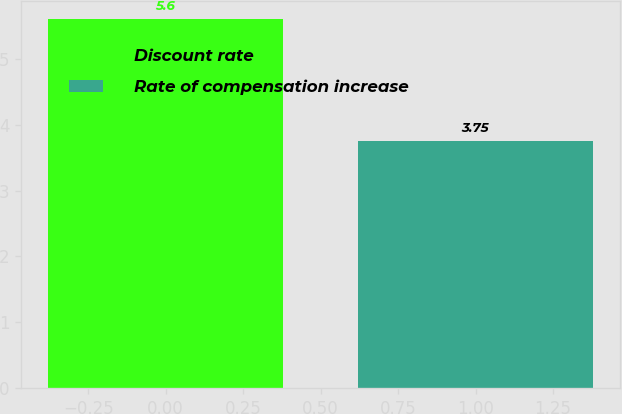Convert chart. <chart><loc_0><loc_0><loc_500><loc_500><bar_chart><fcel>Discount rate<fcel>Rate of compensation increase<nl><fcel>5.6<fcel>3.75<nl></chart> 